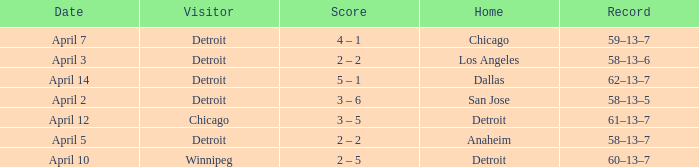What is the date of the game that had a visitor of Chicago? April 12. 